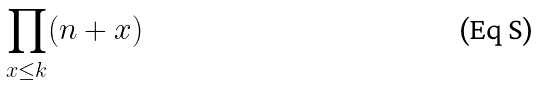<formula> <loc_0><loc_0><loc_500><loc_500>\prod _ { x \leq k } ( n + x )</formula> 